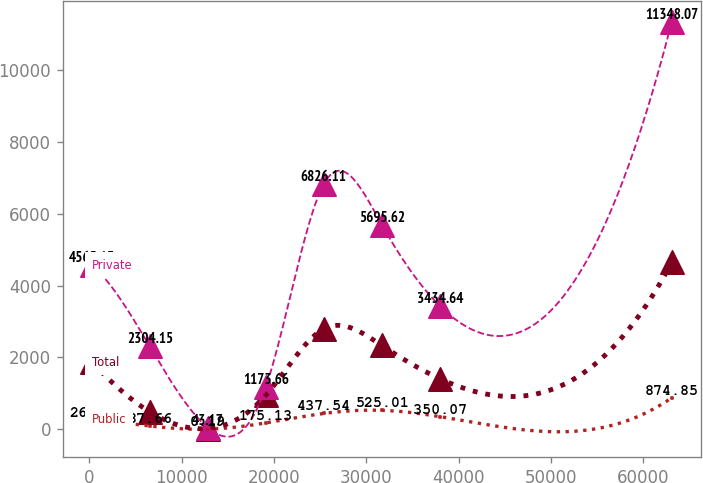Convert chart. <chart><loc_0><loc_0><loc_500><loc_500><line_chart><ecel><fcel>Public<fcel>Total<fcel>Private<nl><fcel>285.82<fcel>262.6<fcel>1869.46<fcel>4565.13<nl><fcel>6566.05<fcel>87.66<fcel>481.3<fcel>2304.15<nl><fcel>12846.3<fcel>0.19<fcel>18.58<fcel>43.17<nl><fcel>19126.5<fcel>175.13<fcel>944.02<fcel>1173.66<nl><fcel>25406.7<fcel>437.54<fcel>2794.9<fcel>6826.11<nl><fcel>31687<fcel>525.01<fcel>2332.18<fcel>5695.62<nl><fcel>37967.2<fcel>350.07<fcel>1406.74<fcel>3434.64<nl><fcel>63088.1<fcel>874.85<fcel>4645.78<fcel>11348.1<nl></chart> 